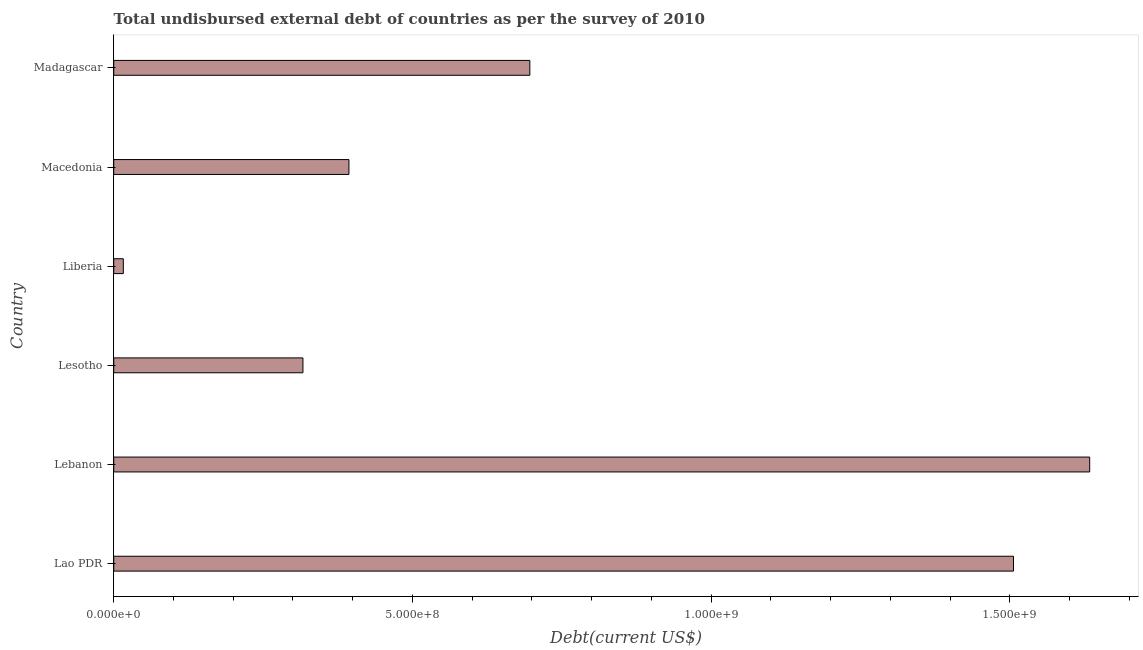Does the graph contain any zero values?
Ensure brevity in your answer.  No. What is the title of the graph?
Give a very brief answer. Total undisbursed external debt of countries as per the survey of 2010. What is the label or title of the X-axis?
Ensure brevity in your answer.  Debt(current US$). What is the label or title of the Y-axis?
Offer a very short reply. Country. What is the total debt in Macedonia?
Provide a succinct answer. 3.94e+08. Across all countries, what is the maximum total debt?
Offer a terse response. 1.63e+09. Across all countries, what is the minimum total debt?
Make the answer very short. 1.60e+07. In which country was the total debt maximum?
Provide a succinct answer. Lebanon. In which country was the total debt minimum?
Offer a very short reply. Liberia. What is the sum of the total debt?
Give a very brief answer. 4.56e+09. What is the difference between the total debt in Liberia and Madagascar?
Provide a short and direct response. -6.80e+08. What is the average total debt per country?
Provide a short and direct response. 7.60e+08. What is the median total debt?
Give a very brief answer. 5.45e+08. In how many countries, is the total debt greater than 1300000000 US$?
Your answer should be very brief. 2. What is the ratio of the total debt in Macedonia to that in Madagascar?
Your answer should be very brief. 0.56. What is the difference between the highest and the second highest total debt?
Your response must be concise. 1.28e+08. Is the sum of the total debt in Liberia and Macedonia greater than the maximum total debt across all countries?
Provide a succinct answer. No. What is the difference between the highest and the lowest total debt?
Your response must be concise. 1.62e+09. In how many countries, is the total debt greater than the average total debt taken over all countries?
Offer a terse response. 2. How many bars are there?
Ensure brevity in your answer.  6. What is the difference between two consecutive major ticks on the X-axis?
Offer a very short reply. 5.00e+08. What is the Debt(current US$) of Lao PDR?
Your answer should be compact. 1.51e+09. What is the Debt(current US$) in Lebanon?
Make the answer very short. 1.63e+09. What is the Debt(current US$) of Lesotho?
Make the answer very short. 3.17e+08. What is the Debt(current US$) in Liberia?
Provide a short and direct response. 1.60e+07. What is the Debt(current US$) in Macedonia?
Your response must be concise. 3.94e+08. What is the Debt(current US$) of Madagascar?
Provide a succinct answer. 6.97e+08. What is the difference between the Debt(current US$) in Lao PDR and Lebanon?
Your response must be concise. -1.28e+08. What is the difference between the Debt(current US$) in Lao PDR and Lesotho?
Your answer should be very brief. 1.19e+09. What is the difference between the Debt(current US$) in Lao PDR and Liberia?
Offer a terse response. 1.49e+09. What is the difference between the Debt(current US$) in Lao PDR and Macedonia?
Provide a short and direct response. 1.11e+09. What is the difference between the Debt(current US$) in Lao PDR and Madagascar?
Give a very brief answer. 8.10e+08. What is the difference between the Debt(current US$) in Lebanon and Lesotho?
Offer a very short reply. 1.32e+09. What is the difference between the Debt(current US$) in Lebanon and Liberia?
Your answer should be compact. 1.62e+09. What is the difference between the Debt(current US$) in Lebanon and Macedonia?
Your response must be concise. 1.24e+09. What is the difference between the Debt(current US$) in Lebanon and Madagascar?
Offer a very short reply. 9.37e+08. What is the difference between the Debt(current US$) in Lesotho and Liberia?
Make the answer very short. 3.01e+08. What is the difference between the Debt(current US$) in Lesotho and Macedonia?
Your answer should be compact. -7.70e+07. What is the difference between the Debt(current US$) in Lesotho and Madagascar?
Your response must be concise. -3.80e+08. What is the difference between the Debt(current US$) in Liberia and Macedonia?
Your answer should be very brief. -3.78e+08. What is the difference between the Debt(current US$) in Liberia and Madagascar?
Make the answer very short. -6.80e+08. What is the difference between the Debt(current US$) in Macedonia and Madagascar?
Your answer should be compact. -3.03e+08. What is the ratio of the Debt(current US$) in Lao PDR to that in Lebanon?
Keep it short and to the point. 0.92. What is the ratio of the Debt(current US$) in Lao PDR to that in Lesotho?
Give a very brief answer. 4.76. What is the ratio of the Debt(current US$) in Lao PDR to that in Liberia?
Offer a very short reply. 93.84. What is the ratio of the Debt(current US$) in Lao PDR to that in Macedonia?
Offer a terse response. 3.83. What is the ratio of the Debt(current US$) in Lao PDR to that in Madagascar?
Keep it short and to the point. 2.16. What is the ratio of the Debt(current US$) in Lebanon to that in Lesotho?
Provide a succinct answer. 5.16. What is the ratio of the Debt(current US$) in Lebanon to that in Liberia?
Your response must be concise. 101.79. What is the ratio of the Debt(current US$) in Lebanon to that in Macedonia?
Your answer should be very brief. 4.15. What is the ratio of the Debt(current US$) in Lebanon to that in Madagascar?
Keep it short and to the point. 2.35. What is the ratio of the Debt(current US$) in Lesotho to that in Liberia?
Your answer should be compact. 19.73. What is the ratio of the Debt(current US$) in Lesotho to that in Macedonia?
Your response must be concise. 0.8. What is the ratio of the Debt(current US$) in Lesotho to that in Madagascar?
Your response must be concise. 0.46. What is the ratio of the Debt(current US$) in Liberia to that in Macedonia?
Provide a succinct answer. 0.04. What is the ratio of the Debt(current US$) in Liberia to that in Madagascar?
Provide a succinct answer. 0.02. What is the ratio of the Debt(current US$) in Macedonia to that in Madagascar?
Ensure brevity in your answer.  0.56. 